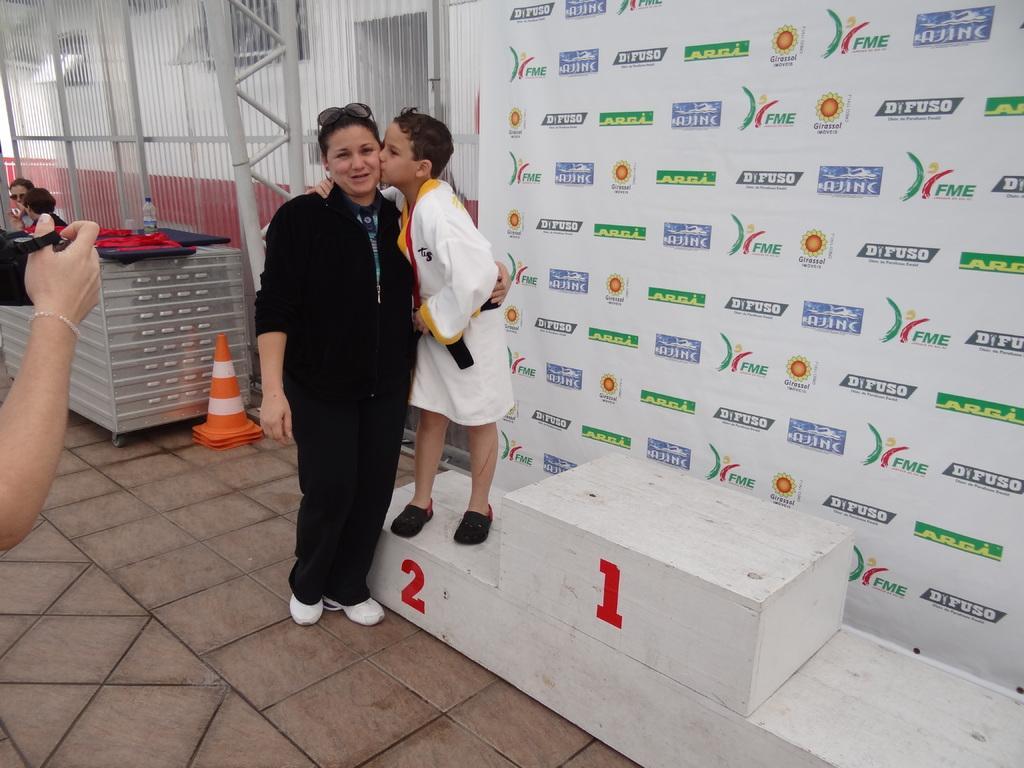In one or two sentences, can you explain what this image depicts? In this image we can see people, wooden stand, traffic cone, bottle, floor, and few objects. There are poles, wall, and a banner. 